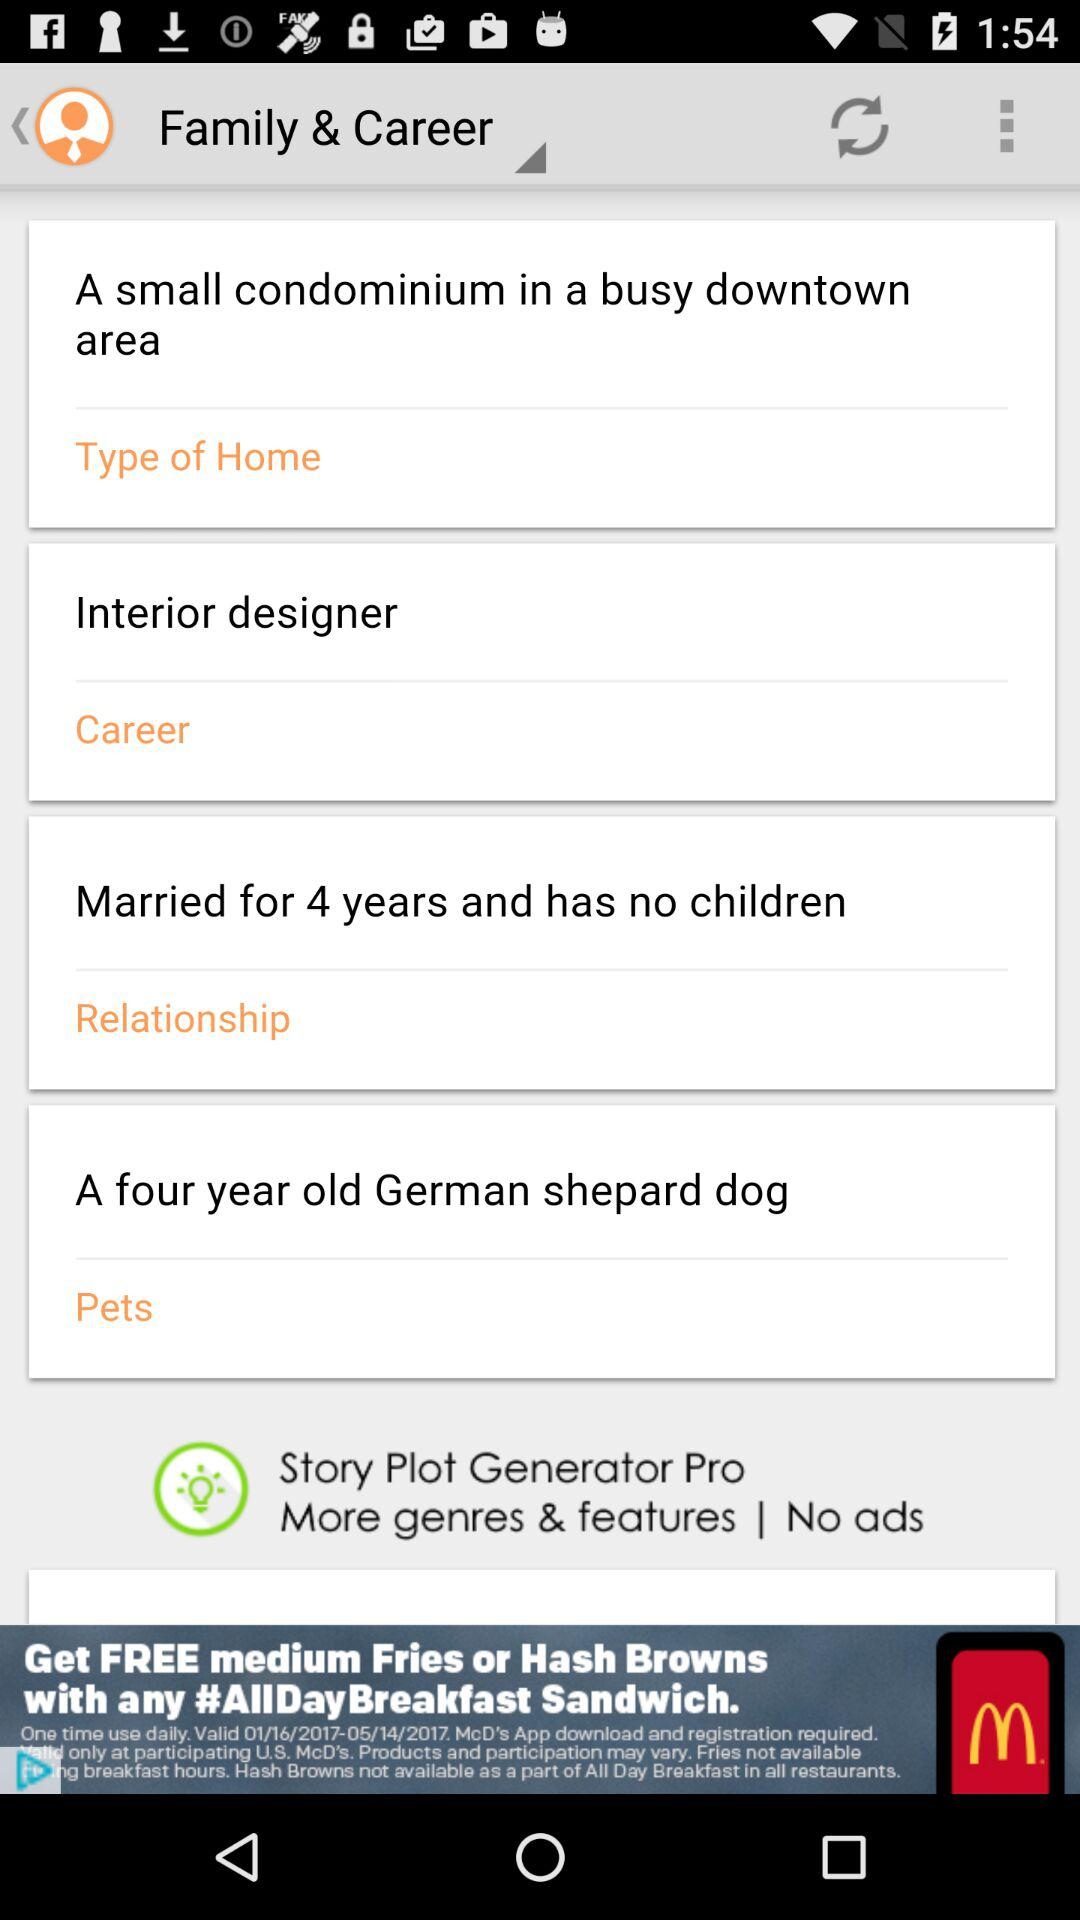What is the career choice? The career choice is "Interior designer". 